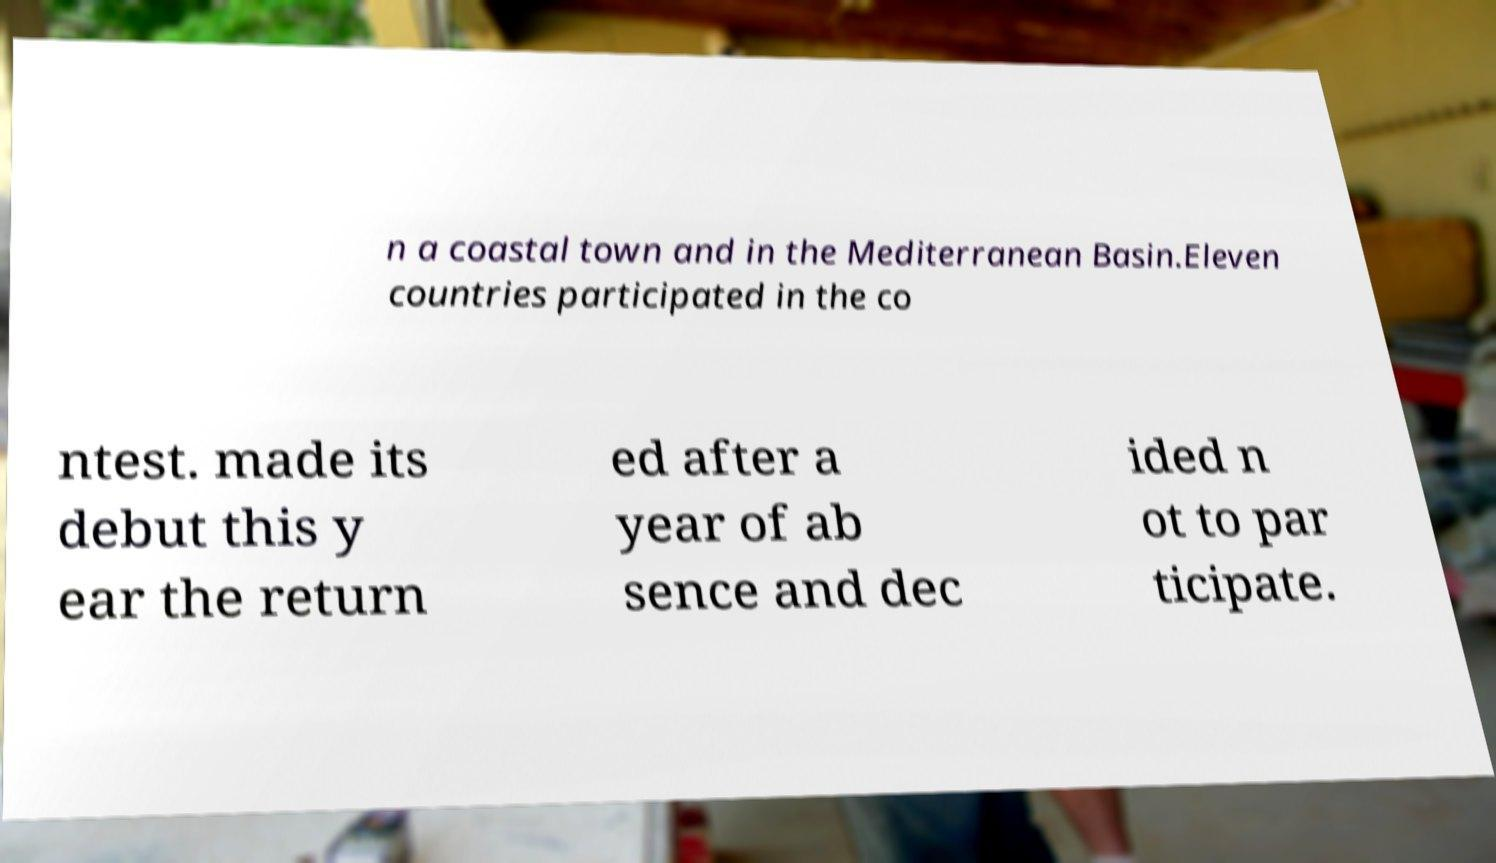For documentation purposes, I need the text within this image transcribed. Could you provide that? n a coastal town and in the Mediterranean Basin.Eleven countries participated in the co ntest. made its debut this y ear the return ed after a year of ab sence and dec ided n ot to par ticipate. 